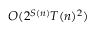<formula> <loc_0><loc_0><loc_500><loc_500>O ( 2 ^ { S ( n ) } T ( n ) ^ { 2 } )</formula> 